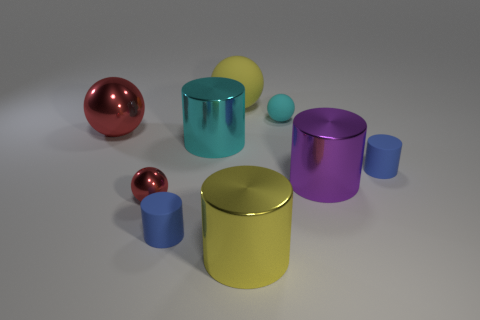What is the shape of the cyan matte object?
Give a very brief answer. Sphere. What number of yellow things have the same material as the large purple cylinder?
Offer a terse response. 1. The small sphere that is made of the same material as the cyan cylinder is what color?
Your answer should be compact. Red. There is a yellow matte thing; does it have the same size as the rubber cylinder on the left side of the large yellow cylinder?
Your answer should be very brief. No. There is a large yellow object in front of the large sphere behind the red object behind the large cyan cylinder; what is it made of?
Make the answer very short. Metal. What number of things are tiny shiny things or red shiny balls?
Make the answer very short. 2. There is a large cylinder on the left side of the big rubber ball; is it the same color as the sphere behind the small cyan rubber ball?
Your response must be concise. No. There is a red metal thing that is the same size as the yellow rubber sphere; what shape is it?
Provide a short and direct response. Sphere. What number of things are large objects that are to the left of the large matte object or cylinders in front of the big cyan object?
Keep it short and to the point. 6. Are there fewer large shiny cylinders than purple rubber cubes?
Your answer should be very brief. No. 